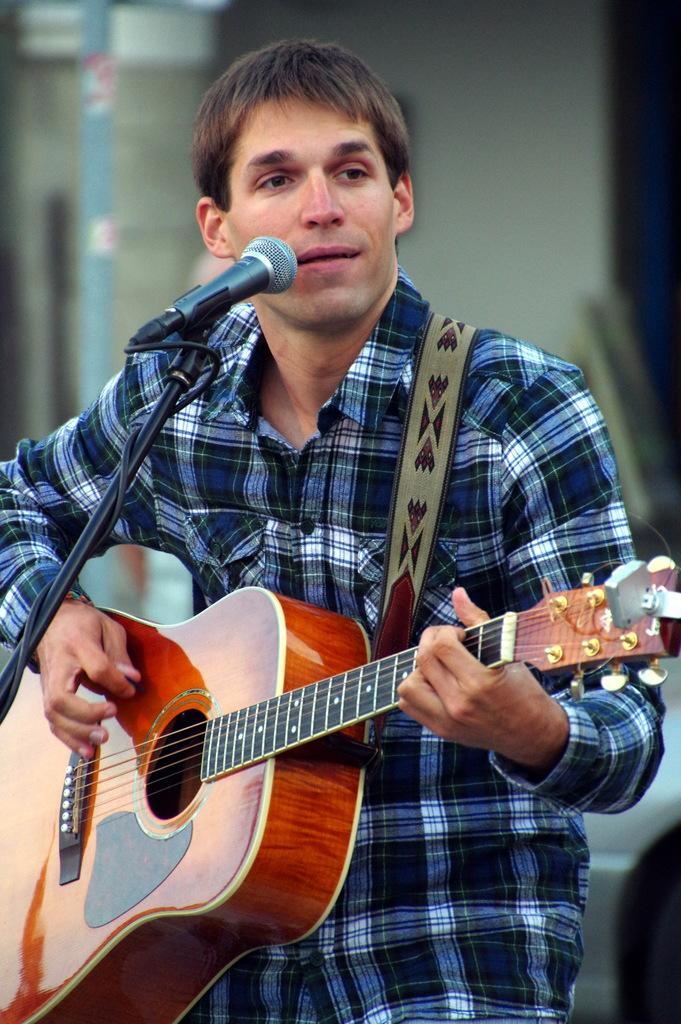Please provide a concise description of this image. this picture shows a man playing a guitar and singing with the help of a microphone 